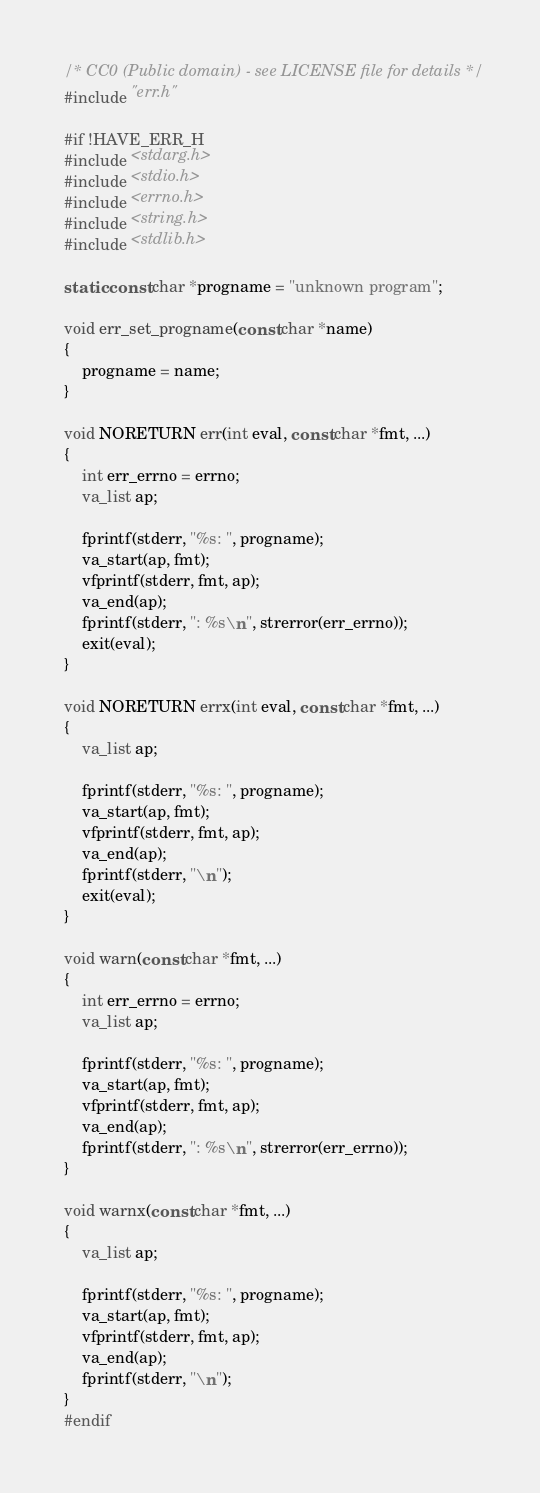Convert code to text. <code><loc_0><loc_0><loc_500><loc_500><_C_>/* CC0 (Public domain) - see LICENSE file for details */
#include "err.h"

#if !HAVE_ERR_H
#include <stdarg.h>
#include <stdio.h>
#include <errno.h>
#include <string.h>
#include <stdlib.h>

static const char *progname = "unknown program";

void err_set_progname(const char *name)
{
	progname = name;
}

void NORETURN err(int eval, const char *fmt, ...)
{
	int err_errno = errno;
	va_list ap;

	fprintf(stderr, "%s: ", progname);
	va_start(ap, fmt);
	vfprintf(stderr, fmt, ap);
	va_end(ap);
	fprintf(stderr, ": %s\n", strerror(err_errno));
	exit(eval);
}

void NORETURN errx(int eval, const char *fmt, ...)
{
	va_list ap;

	fprintf(stderr, "%s: ", progname);
	va_start(ap, fmt);
	vfprintf(stderr, fmt, ap);
	va_end(ap);
	fprintf(stderr, "\n");
	exit(eval);
}

void warn(const char *fmt, ...)
{
	int err_errno = errno;
	va_list ap;

	fprintf(stderr, "%s: ", progname);
	va_start(ap, fmt);
	vfprintf(stderr, fmt, ap);
	va_end(ap);
	fprintf(stderr, ": %s\n", strerror(err_errno));
}

void warnx(const char *fmt, ...)
{
	va_list ap;

	fprintf(stderr, "%s: ", progname);
	va_start(ap, fmt);
	vfprintf(stderr, fmt, ap);
	va_end(ap);
	fprintf(stderr, "\n");
}
#endif
</code> 